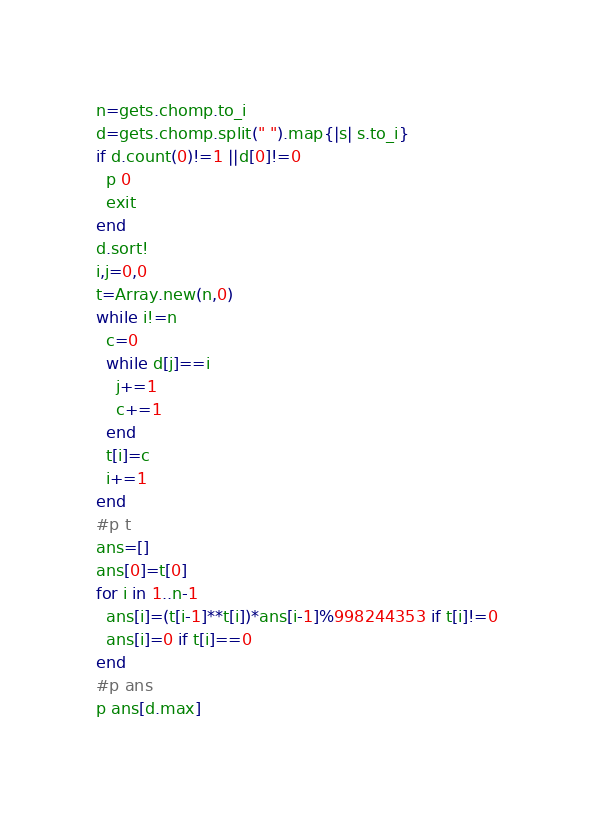Convert code to text. <code><loc_0><loc_0><loc_500><loc_500><_Ruby_>n=gets.chomp.to_i
d=gets.chomp.split(" ").map{|s| s.to_i}
if d.count(0)!=1 ||d[0]!=0
  p 0
  exit
end
d.sort!
i,j=0,0
t=Array.new(n,0)
while i!=n
  c=0
  while d[j]==i
    j+=1
    c+=1
  end
  t[i]=c
  i+=1
end
#p t
ans=[]
ans[0]=t[0]
for i in 1..n-1
  ans[i]=(t[i-1]**t[i])*ans[i-1]%998244353 if t[i]!=0
  ans[i]=0 if t[i]==0
end
#p ans
p ans[d.max]</code> 